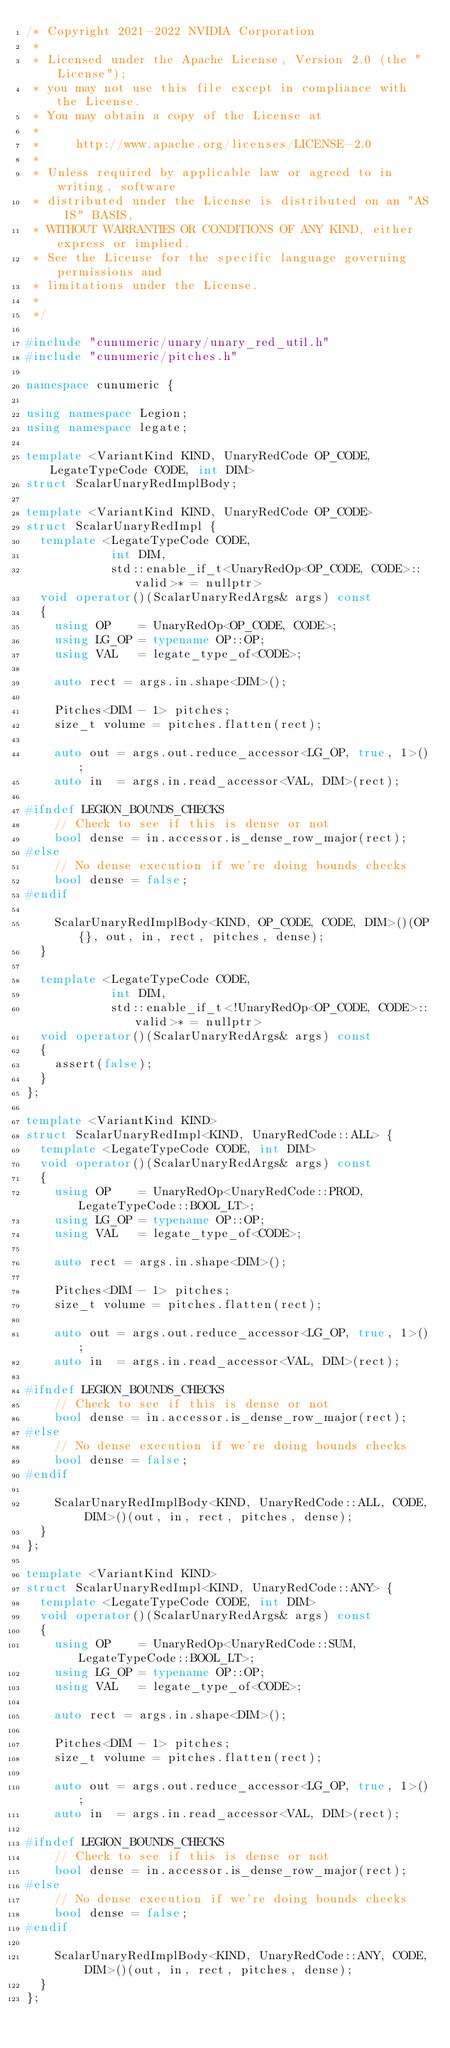<code> <loc_0><loc_0><loc_500><loc_500><_C++_>/* Copyright 2021-2022 NVIDIA Corporation
 *
 * Licensed under the Apache License, Version 2.0 (the "License");
 * you may not use this file except in compliance with the License.
 * You may obtain a copy of the License at
 *
 *     http://www.apache.org/licenses/LICENSE-2.0
 *
 * Unless required by applicable law or agreed to in writing, software
 * distributed under the License is distributed on an "AS IS" BASIS,
 * WITHOUT WARRANTIES OR CONDITIONS OF ANY KIND, either express or implied.
 * See the License for the specific language governing permissions and
 * limitations under the License.
 *
 */

#include "cunumeric/unary/unary_red_util.h"
#include "cunumeric/pitches.h"

namespace cunumeric {

using namespace Legion;
using namespace legate;

template <VariantKind KIND, UnaryRedCode OP_CODE, LegateTypeCode CODE, int DIM>
struct ScalarUnaryRedImplBody;

template <VariantKind KIND, UnaryRedCode OP_CODE>
struct ScalarUnaryRedImpl {
  template <LegateTypeCode CODE,
            int DIM,
            std::enable_if_t<UnaryRedOp<OP_CODE, CODE>::valid>* = nullptr>
  void operator()(ScalarUnaryRedArgs& args) const
  {
    using OP    = UnaryRedOp<OP_CODE, CODE>;
    using LG_OP = typename OP::OP;
    using VAL   = legate_type_of<CODE>;

    auto rect = args.in.shape<DIM>();

    Pitches<DIM - 1> pitches;
    size_t volume = pitches.flatten(rect);

    auto out = args.out.reduce_accessor<LG_OP, true, 1>();
    auto in  = args.in.read_accessor<VAL, DIM>(rect);

#ifndef LEGION_BOUNDS_CHECKS
    // Check to see if this is dense or not
    bool dense = in.accessor.is_dense_row_major(rect);
#else
    // No dense execution if we're doing bounds checks
    bool dense = false;
#endif

    ScalarUnaryRedImplBody<KIND, OP_CODE, CODE, DIM>()(OP{}, out, in, rect, pitches, dense);
  }

  template <LegateTypeCode CODE,
            int DIM,
            std::enable_if_t<!UnaryRedOp<OP_CODE, CODE>::valid>* = nullptr>
  void operator()(ScalarUnaryRedArgs& args) const
  {
    assert(false);
  }
};

template <VariantKind KIND>
struct ScalarUnaryRedImpl<KIND, UnaryRedCode::ALL> {
  template <LegateTypeCode CODE, int DIM>
  void operator()(ScalarUnaryRedArgs& args) const
  {
    using OP    = UnaryRedOp<UnaryRedCode::PROD, LegateTypeCode::BOOL_LT>;
    using LG_OP = typename OP::OP;
    using VAL   = legate_type_of<CODE>;

    auto rect = args.in.shape<DIM>();

    Pitches<DIM - 1> pitches;
    size_t volume = pitches.flatten(rect);

    auto out = args.out.reduce_accessor<LG_OP, true, 1>();
    auto in  = args.in.read_accessor<VAL, DIM>(rect);

#ifndef LEGION_BOUNDS_CHECKS
    // Check to see if this is dense or not
    bool dense = in.accessor.is_dense_row_major(rect);
#else
    // No dense execution if we're doing bounds checks
    bool dense = false;
#endif

    ScalarUnaryRedImplBody<KIND, UnaryRedCode::ALL, CODE, DIM>()(out, in, rect, pitches, dense);
  }
};

template <VariantKind KIND>
struct ScalarUnaryRedImpl<KIND, UnaryRedCode::ANY> {
  template <LegateTypeCode CODE, int DIM>
  void operator()(ScalarUnaryRedArgs& args) const
  {
    using OP    = UnaryRedOp<UnaryRedCode::SUM, LegateTypeCode::BOOL_LT>;
    using LG_OP = typename OP::OP;
    using VAL   = legate_type_of<CODE>;

    auto rect = args.in.shape<DIM>();

    Pitches<DIM - 1> pitches;
    size_t volume = pitches.flatten(rect);

    auto out = args.out.reduce_accessor<LG_OP, true, 1>();
    auto in  = args.in.read_accessor<VAL, DIM>(rect);

#ifndef LEGION_BOUNDS_CHECKS
    // Check to see if this is dense or not
    bool dense = in.accessor.is_dense_row_major(rect);
#else
    // No dense execution if we're doing bounds checks
    bool dense = false;
#endif

    ScalarUnaryRedImplBody<KIND, UnaryRedCode::ANY, CODE, DIM>()(out, in, rect, pitches, dense);
  }
};
</code> 